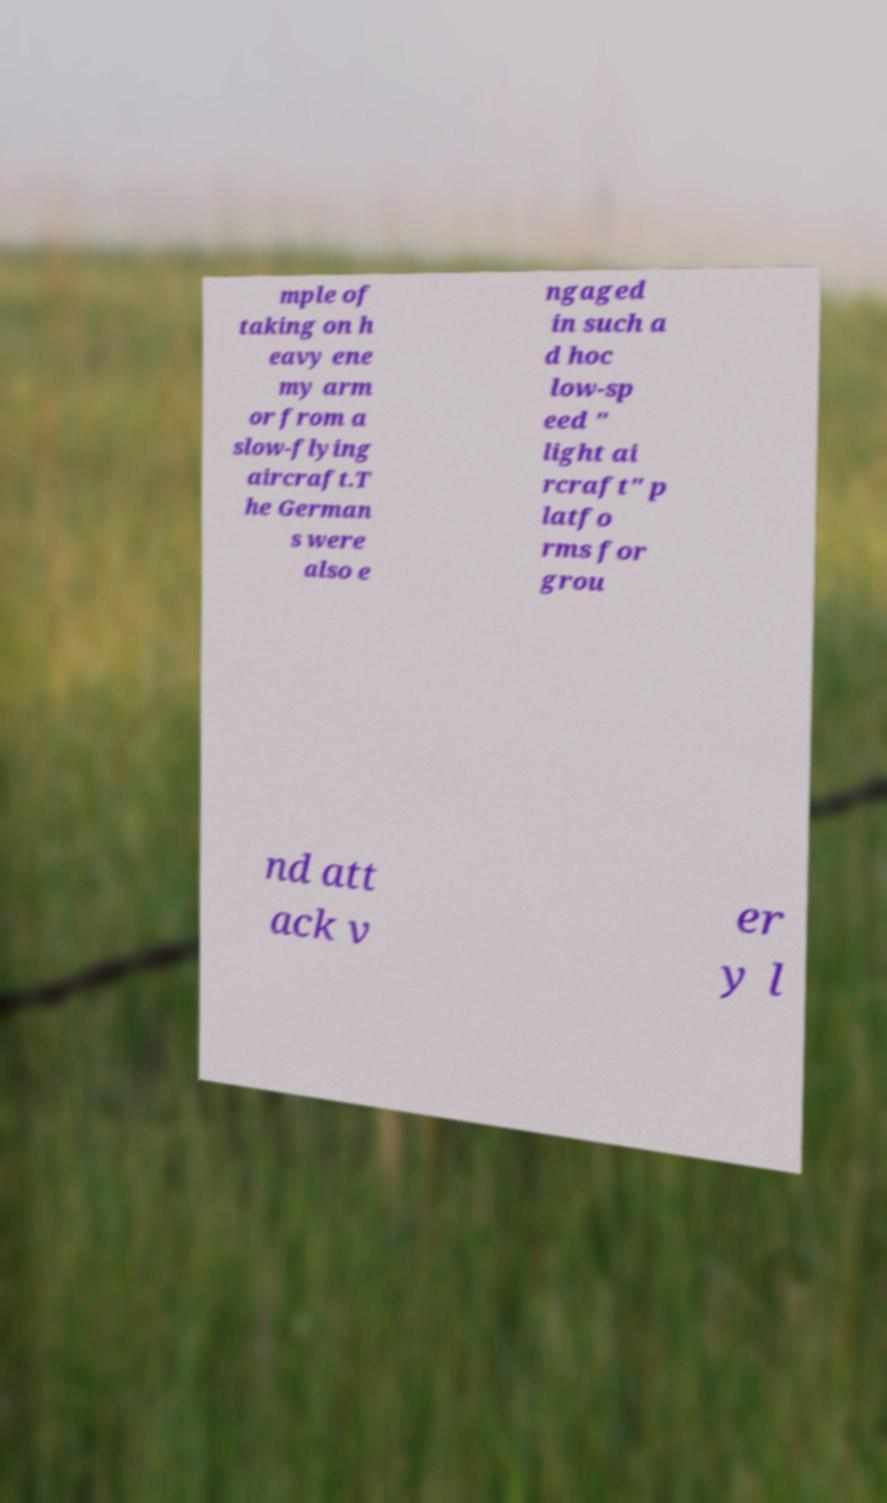Could you extract and type out the text from this image? mple of taking on h eavy ene my arm or from a slow-flying aircraft.T he German s were also e ngaged in such a d hoc low-sp eed " light ai rcraft" p latfo rms for grou nd att ack v er y l 